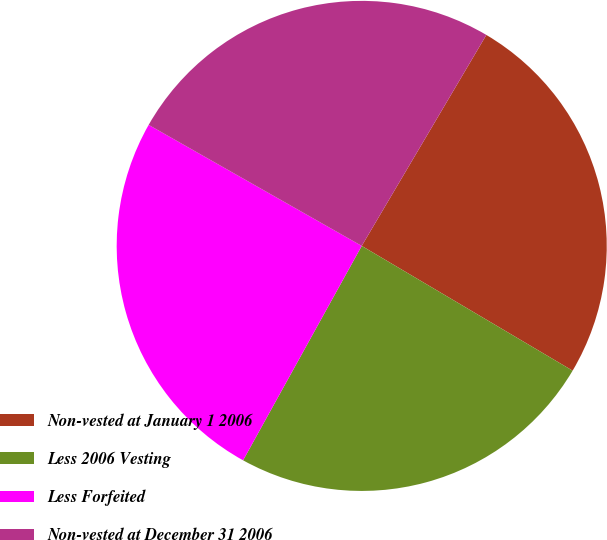Convert chart. <chart><loc_0><loc_0><loc_500><loc_500><pie_chart><fcel>Non-vested at January 1 2006<fcel>Less 2006 Vesting<fcel>Less Forfeited<fcel>Non-vested at December 31 2006<nl><fcel>25.01%<fcel>24.54%<fcel>25.18%<fcel>25.27%<nl></chart> 